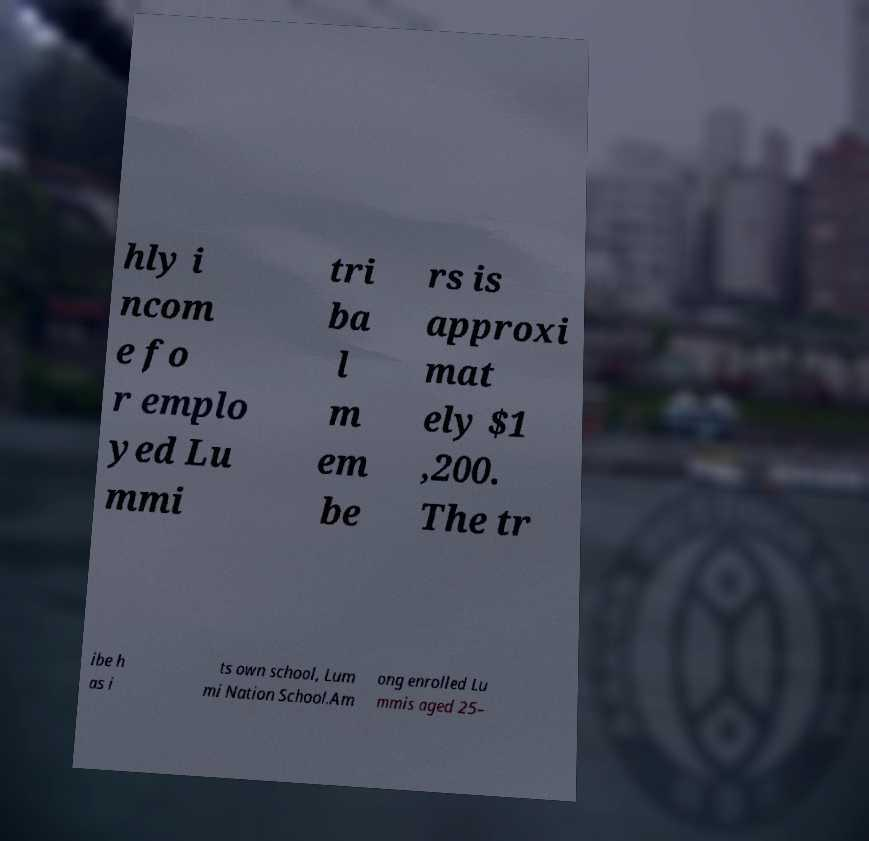Can you accurately transcribe the text from the provided image for me? hly i ncom e fo r emplo yed Lu mmi tri ba l m em be rs is approxi mat ely $1 ,200. The tr ibe h as i ts own school, Lum mi Nation School.Am ong enrolled Lu mmis aged 25– 